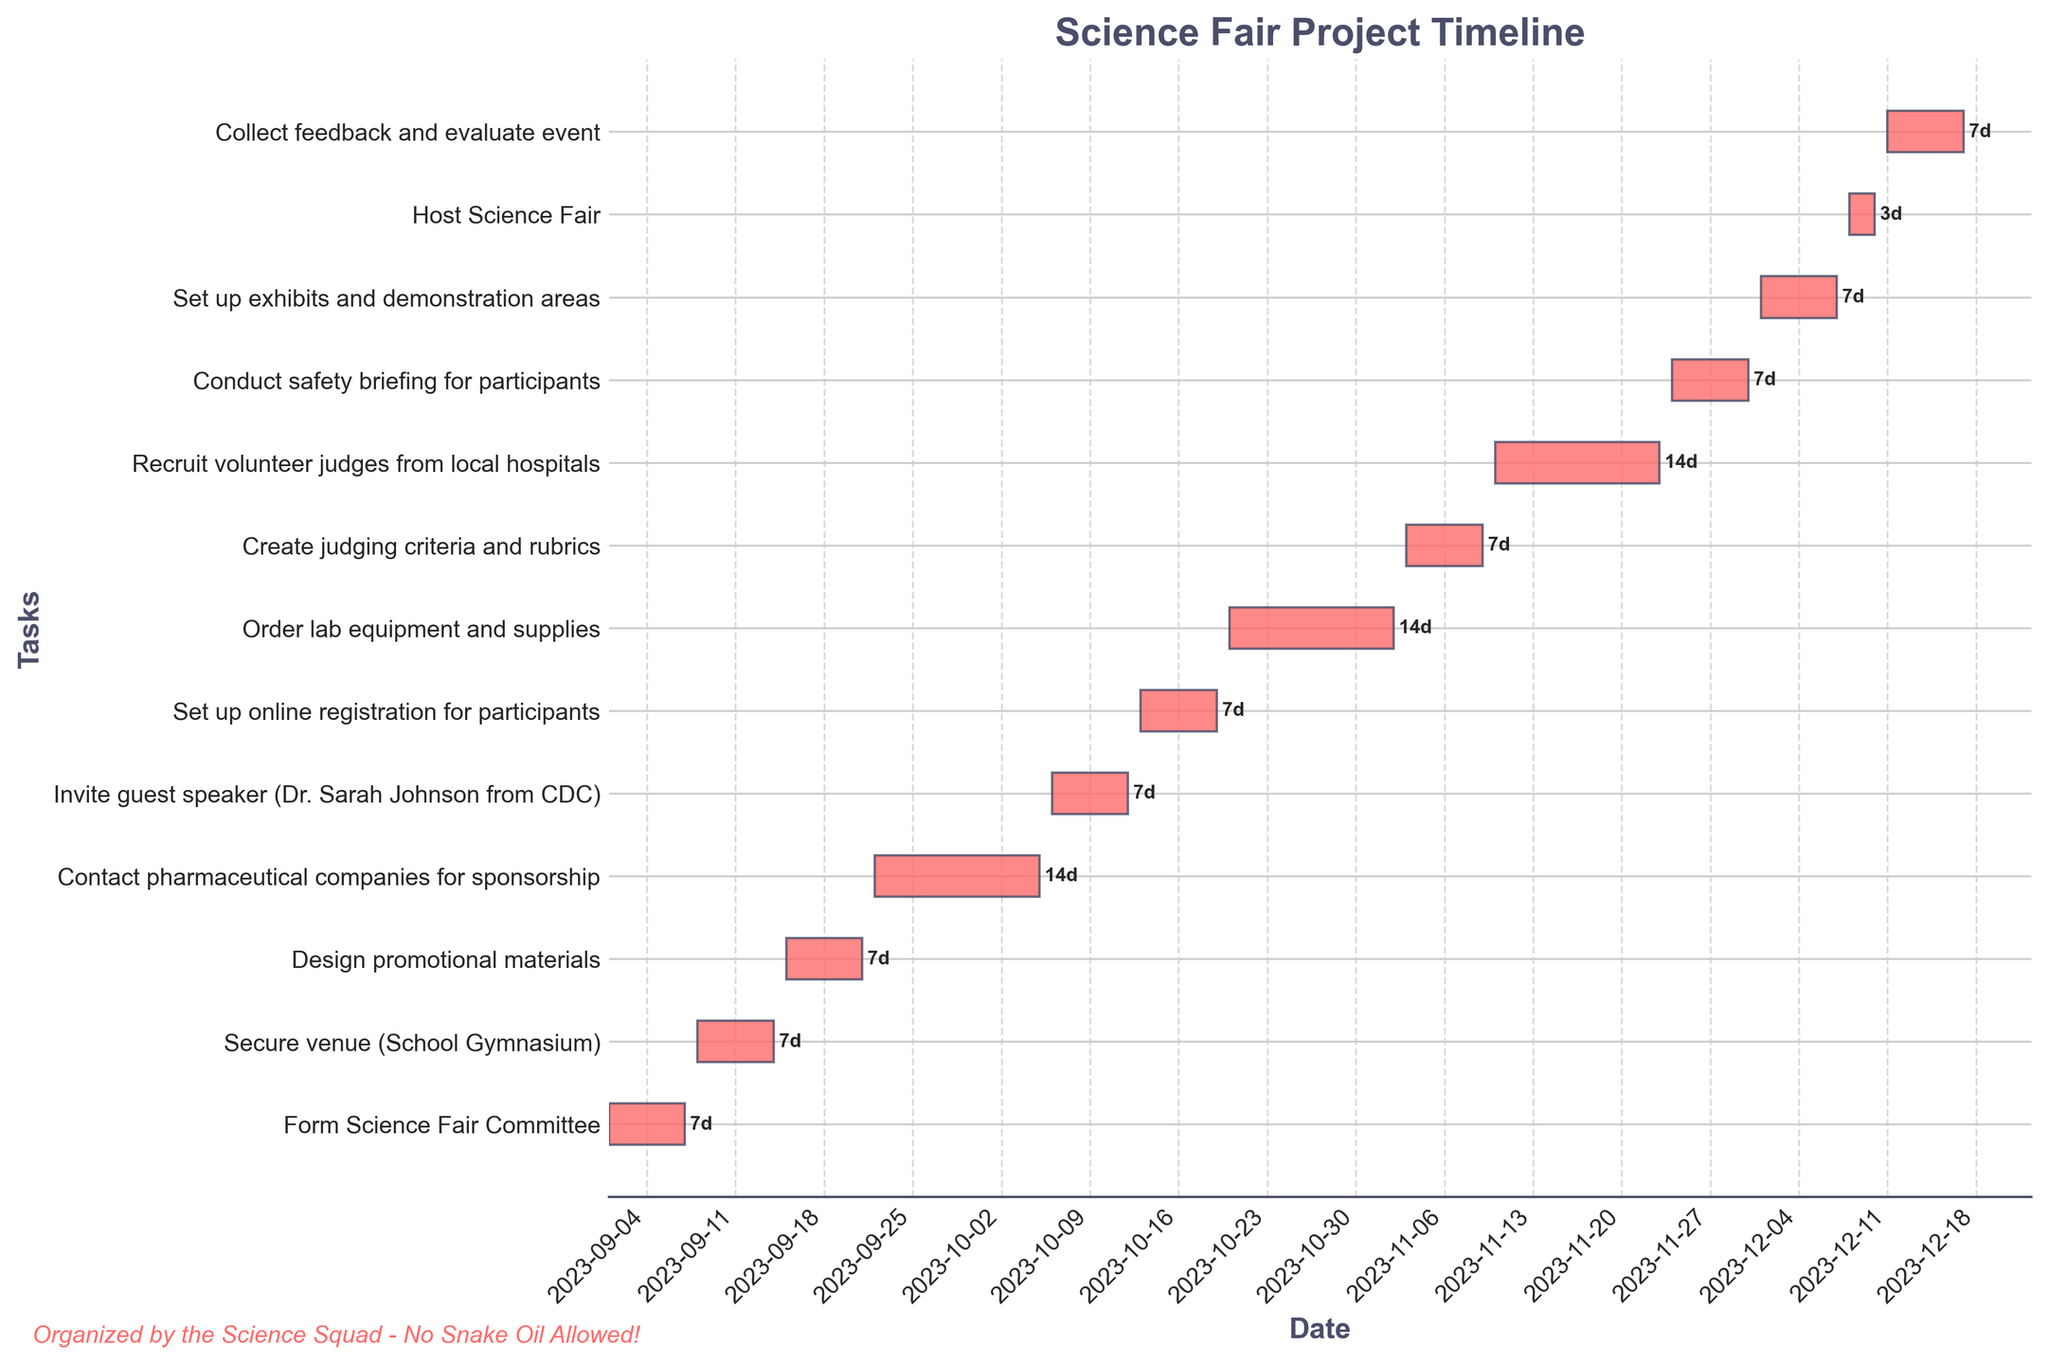What is the title of the Gantt chart? The title is located at the top of the chart, which typically indicates the overall theme or purpose of the timeline being displayed. Here, it reads "Science Fair Project Timeline".
Answer: Science Fair Project Timeline Which tasks have a duration of 14 days? Tasks with their durations printed next to the bars on the right side of the chart and those that span two weeks on the timeline axis are likely the ones with a 14-day duration. These tasks are "Contact pharmaceutical companies for sponsorship", "Order lab equipment and supplies", and "Recruit volunteer judges from local hospitals".
Answer: Contact pharmaceutical companies for sponsorship, Order lab equipment and supplies, Recruit volunteer judges from local hospitals When does the task "Set up exhibits and demonstration areas" begin and end? Locate the task "Set up exhibits and demonstration areas" on the y-axis of the chart, and then refer to its corresponding bars on the x-axis to find the start and end dates. It starts on 2023-12-01 and ends on 2023-12-07.
Answer: 2023-12-01 to 2023-12-07 Which task immediately follows "Invite guest speaker (Dr. Sarah Johnson from CDC)"? Identify the end date of the task "Invite guest speaker (Dr. Sarah Johnson from CDC)", and then find the task that starts right after this end date on the chart. The next task is "Set up online registration for participants".
Answer: Set up online registration for participants Which two tasks are of the shortest duration, and how long do they last? The durations are shown next to each bar on the chart. By identifying the tasks with the smallest value, you'll see that "Host Science Fair" has the shortest duration of 3 days.
Answer: Host Science Fair, 3 days How many tasks are scheduled to start in November 2023? Examine the start dates of the tasks shown along the timeline in the chart. Identify the ones starting from 2023-11-01 to 2023-11-30. The tasks are "Create judging criteria and rubrics", "Recruit volunteer judges from local hospitals", and "Conduct safety briefing for participants". There are 3 tasks starting in November 2023.
Answer: 3 tasks Which task has the latest end date, and what is its date? Identify the task that extends farthest to the right on the x-axis where the timeline is located. This is the task "Collect feedback and evaluate event", ending on 2023-12-17.
Answer: Collect feedback and evaluate event, 2023-12-17 How long after the "Secure venue (School Gymnasium)" task does "Order lab equipment and supplies" begin? “Secure venue (School Gymnasium)” ends on 2023-09-14, and “Order lab equipment and supplies” begins on 2023-10-20. Calculate the number of days between the end of the first task and the start of the second task. This is 36 days (from 2023-09-14 to 2023-10-20).
Answer: 36 days How many days are allocated for the "Create judging criteria and rubrics" task? Next to the bars representing the "Create judging criteria and rubrics" task on the y-axis, the duration is shown. It indicates 7 days.
Answer: 7 days 